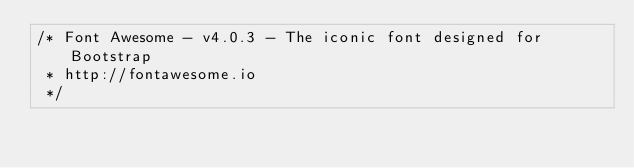Convert code to text. <code><loc_0><loc_0><loc_500><loc_500><_CSS_>/* Font Awesome - v4.0.3 - The iconic font designed for Bootstrap
 * http://fontawesome.io
 */</code> 